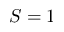<formula> <loc_0><loc_0><loc_500><loc_500>S = 1</formula> 